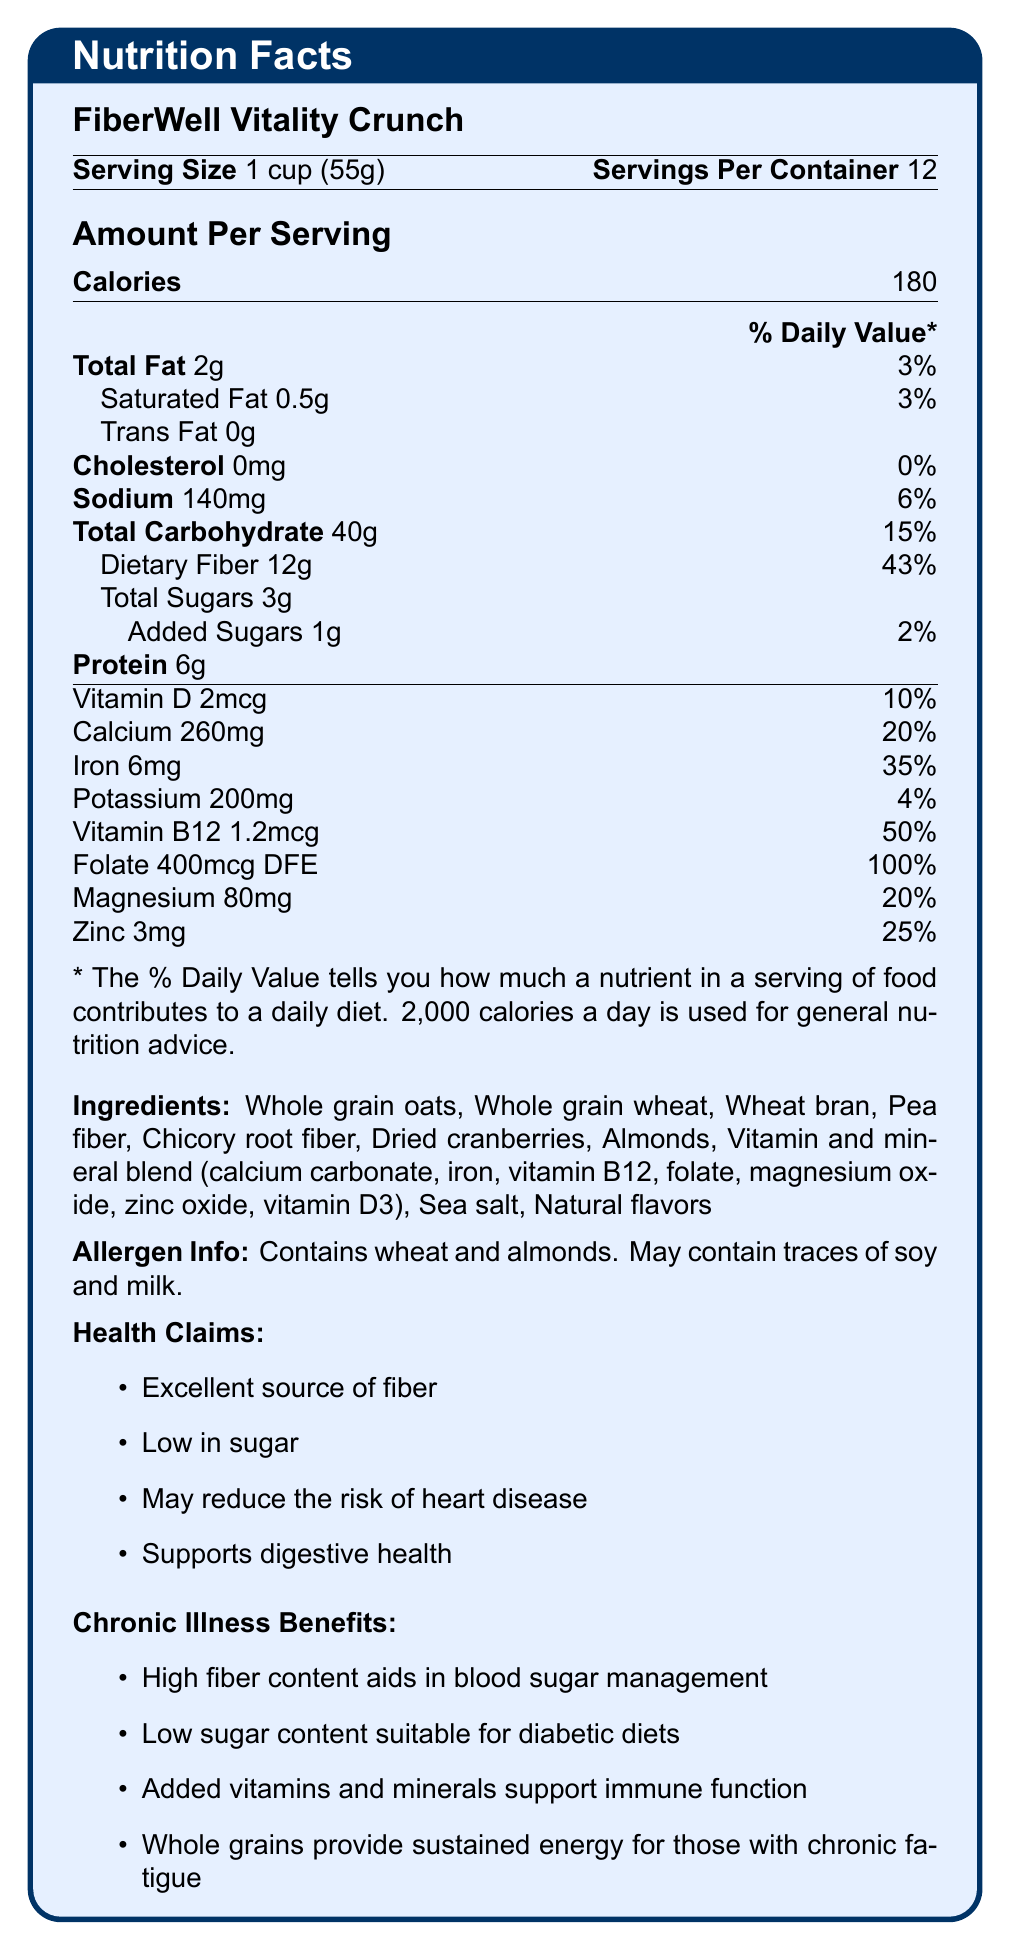what is the serving size for FiberWell Vitality Crunch? The serving size is explicitly stated as 1 cup, which weighs 55 grams.
Answer: 1 cup (55g) how many calories are in one serving of FiberWell Vitality Crunch? The document directly states that there are 180 calories per serving.
Answer: 180 what percentage of the daily value of dietary fiber is provided by one serving? The Nutrition Facts label indicates that one serving provides 43% of the daily value for dietary fiber.
Answer: 43% are there any trans fats in FiberWell Vitality Crunch? The document states that the amount of trans fat per serving is 0g.
Answer: No what allergens are contained in FiberWell Vitality Crunch? The allergen information section lists wheat and almonds as contained allergens.
Answer: Wheat and almonds which vitamins and minerals are added to FiberWell Vitality Crunch? A. Vitamin C, Potassium, Iron B. Vitamin D, Calcium, Iron C. Vitamin A, Magnesium, Sodium The ingredients list includes added vitamins and minerals, including calcium carbonate, iron, vitamin B12, folate, magnesium oxide, zinc oxide, and vitamin D3.
Answer: B. Vitamin D, Calcium, Iron what is the total carbohydrate content per serving, and what percentage of the daily value does this represent? The label states that the total carbohydrate content per serving is 40g, which is 15% of the daily value.
Answer: 40g, 15% how many grams of added sugars are in one serving? A. 1g B. 2g C. 3g D. 0g The document specifies that there are 1g of added sugars per serving.
Answer: A. 1g does FiberWell Vitality Crunch contain any cholesterol? The document states that the amount of cholesterol per serving is 0mg.
Answer: No is FiberWell Vitality Crunch suitable for individuals managing blood sugar levels? The chronic illness benefits section mentions that high fiber content aids in blood sugar management and low sugar content is suitable for diabetic diets.
Answer: Yes summarize the main health benefits of consuming FiberWell Vitality Crunch. The product is an excellent source of fiber, low in sugar, and contains vitamins and minerals. It supports digestive health, aids in managing blood sugar levels, and provides sustained energy due to whole grains.
Answer: It is a high-fiber, low-sugar breakfast cereal with added vitamins and minerals that supports digestive health, aids in blood sugar management, and provides sustained energy. what flavorings are used in FiberWell Vitality Crunch? The document mentions "Natural flavors" in the ingredients list but does not specify which flavorings are used.
Answer: Not enough information 